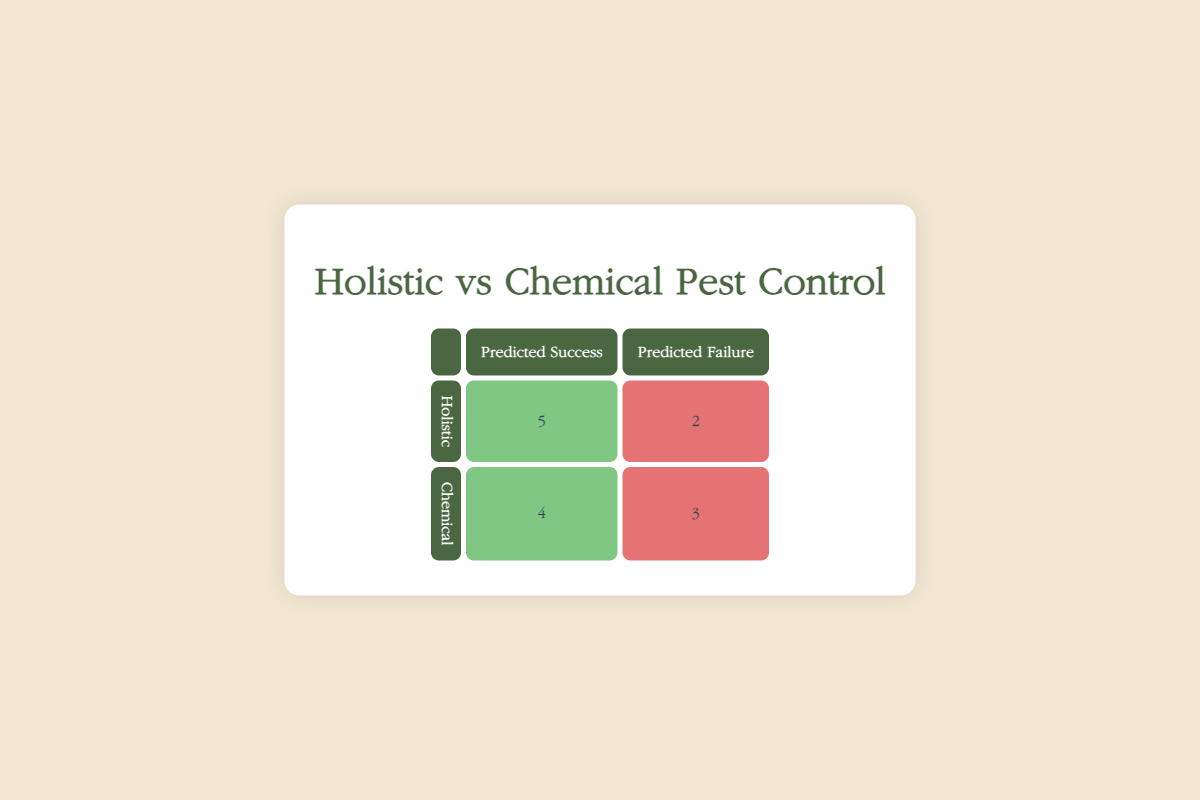What is the total number of successful pest controls using holistic methods? From the table, the number of successes for holistic methods is indicated as 5. This value is explicitly stated in the corresponding cell of the "Holistic" row under "Predicted Success."
Answer: 5 How many failures were recorded for chemical pest control? The table shows that there were 3 failures for chemical methods, which can be found in the "Chemical" row under "Predicted Failure."
Answer: 3 What is the total number of attempts for each method combined? Adding the total number of results in the holistic and chemical rows gives: Holistic (5 successes + 2 failures = 7) + Chemical (4 successes + 3 failures = 7), totaling 7 + 7 = 14 attempts.
Answer: 14 Does the holistic method have a higher success rate than the chemical method? To find this, we compare the success rates: Holistic success rate = 5/7 ≈ 0.71 and Chemical success rate = 4/7 ≈ 0.57. Since 0.71 is greater than 0.57, holistic methods do have a higher success rate.
Answer: Yes What is the difference in the number of successful pest controls between holistic and chemical methods? To find the difference, we subtract the number of chemical successes from holistic successes: 5 (holistic) - 4 (chemical) = 1. Therefore, holistic methods have 1 more success than chemical methods.
Answer: 1 What is the failure rate for chemical methods? The failure rate can be calculated by dividing the number of failures by the total attempts for chemical methods: 3 failures out of 7 attempts yields 3/7 ≈ 0.43 or 43%.
Answer: Approximately 43% Which method had more total outcomes, holistic or chemical? Both methods had 7 outcomes each (5 successes and 2 failures for holistic, and 4 successes and 3 failures for chemical). Thus, they have an equal number of total outcomes.
Answer: No If you had to recommend pest control based on the success predictions, which method would you choose? Based on the success predictions shown (5 successes vs. 4 successes), I would recommend holistic pest control, as it has a higher number of predicted successes compared to chemical methods.
Answer: Holistic 